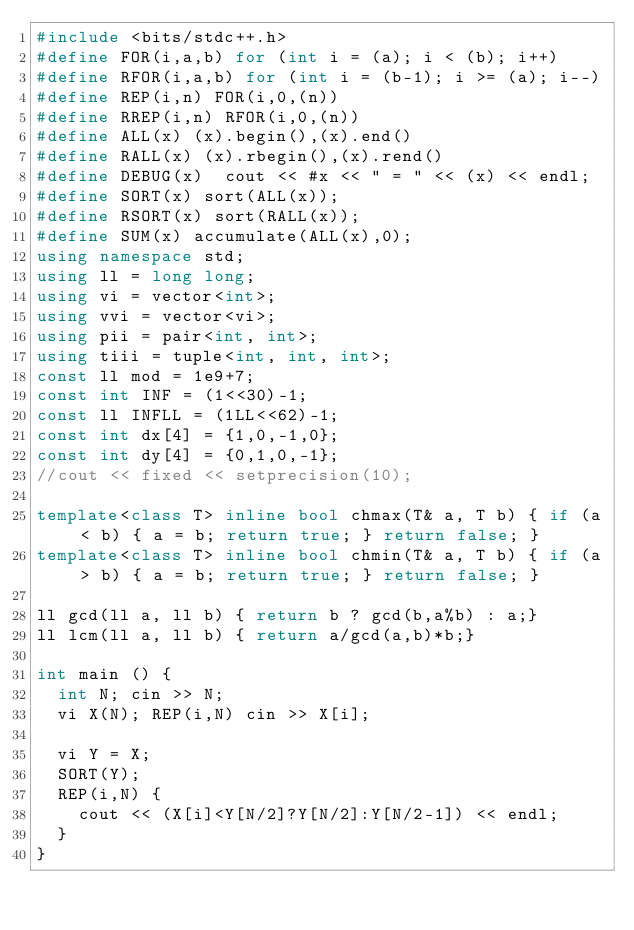<code> <loc_0><loc_0><loc_500><loc_500><_C++_>#include <bits/stdc++.h>
#define FOR(i,a,b) for (int i = (a); i < (b); i++)
#define RFOR(i,a,b) for (int i = (b-1); i >= (a); i--)
#define REP(i,n) FOR(i,0,(n))
#define RREP(i,n) RFOR(i,0,(n))
#define ALL(x) (x).begin(),(x).end()
#define RALL(x) (x).rbegin(),(x).rend()
#define DEBUG(x)  cout << #x << " = " << (x) << endl;
#define SORT(x) sort(ALL(x));
#define RSORT(x) sort(RALL(x));
#define SUM(x) accumulate(ALL(x),0);
using namespace std;
using ll = long long;
using vi = vector<int>;
using vvi = vector<vi>;
using pii = pair<int, int>;
using tiii = tuple<int, int, int>;
const ll mod = 1e9+7;
const int INF = (1<<30)-1;
const ll INFLL = (1LL<<62)-1;
const int dx[4] = {1,0,-1,0};
const int dy[4] = {0,1,0,-1};
//cout << fixed << setprecision(10);

template<class T> inline bool chmax(T& a, T b) { if (a < b) { a = b; return true; } return false; }
template<class T> inline bool chmin(T& a, T b) { if (a > b) { a = b; return true; } return false; }

ll gcd(ll a, ll b) { return b ? gcd(b,a%b) : a;}
ll lcm(ll a, ll b) { return a/gcd(a,b)*b;}

int main () {
  int N; cin >> N;
  vi X(N); REP(i,N) cin >> X[i];

  vi Y = X;
  SORT(Y);
  REP(i,N) {
    cout << (X[i]<Y[N/2]?Y[N/2]:Y[N/2-1]) << endl;
  }
}</code> 